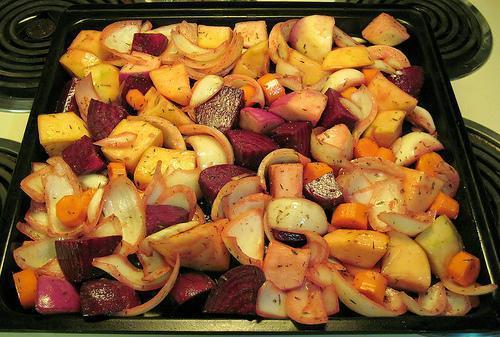How many burners does the stove have?
Give a very brief answer. 4. 